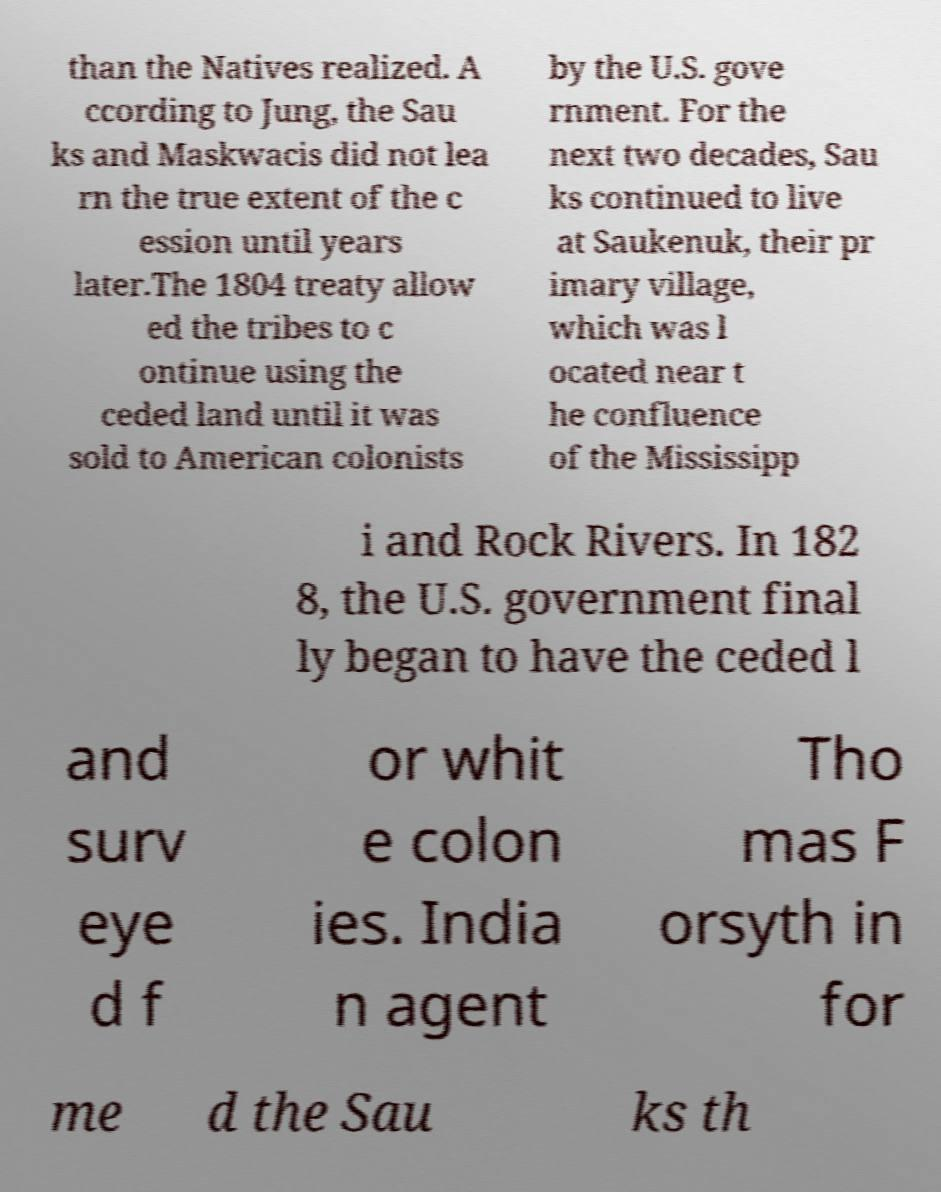Could you extract and type out the text from this image? than the Natives realized. A ccording to Jung, the Sau ks and Maskwacis did not lea rn the true extent of the c ession until years later.The 1804 treaty allow ed the tribes to c ontinue using the ceded land until it was sold to American colonists by the U.S. gove rnment. For the next two decades, Sau ks continued to live at Saukenuk, their pr imary village, which was l ocated near t he confluence of the Mississipp i and Rock Rivers. In 182 8, the U.S. government final ly began to have the ceded l and surv eye d f or whit e colon ies. India n agent Tho mas F orsyth in for me d the Sau ks th 